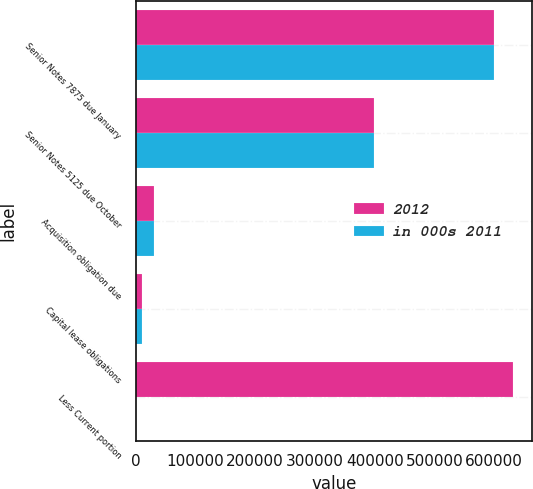Convert chart to OTSL. <chart><loc_0><loc_0><loc_500><loc_500><stacked_bar_chart><ecel><fcel>Senior Notes 7875 due January<fcel>Senior Notes 5125 due October<fcel>Acquisition obligation due<fcel>Capital lease obligations<fcel>Less Current portion<nl><fcel>2012<fcel>599913<fcel>399412<fcel>30831<fcel>10393<fcel>631434<nl><fcel>in 000s 2011<fcel>599788<fcel>399177<fcel>30166<fcel>10953<fcel>557<nl></chart> 